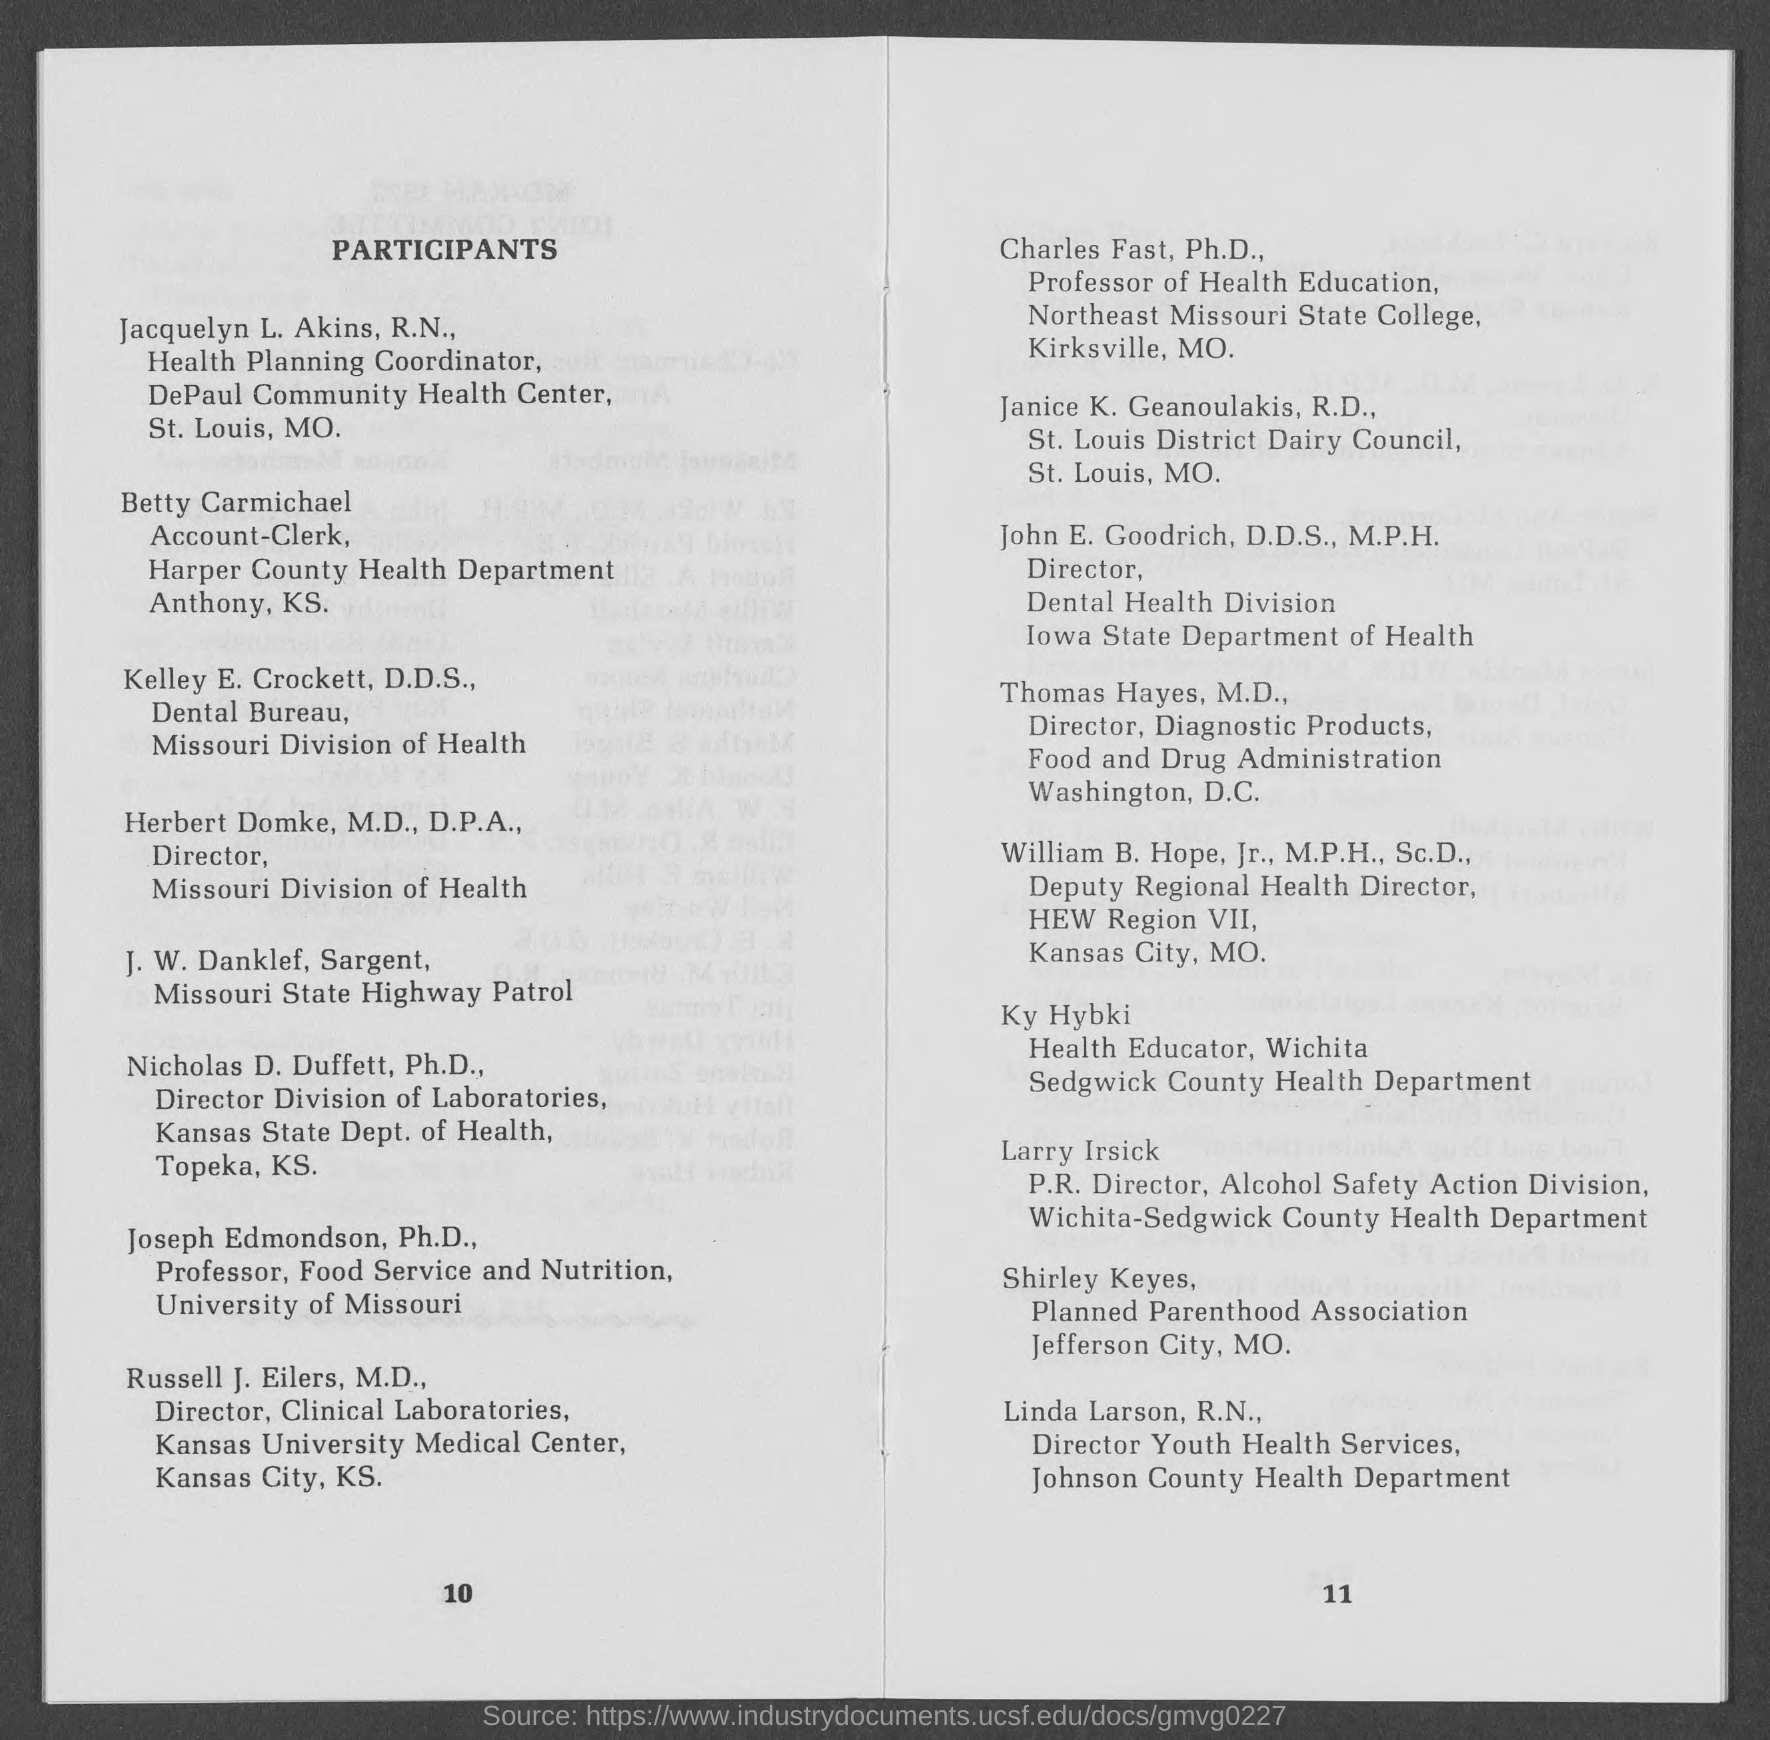What is the heading of document at top-left?
Provide a succinct answer. PARTICIPANTS. Who is the health planning coordinator at st.louis?
Your answer should be compact. JACQUELYN L. AKINS. Who is the account-clerk at anthony. k.s?
Make the answer very short. Betty Carmichael. Who is the director of Missouri Division of Health?
Keep it short and to the point. HERBERT DOMKE, M.D., D.P.A. Who is the director division of laboratories, kansas state dept. of health?
Provide a short and direct response. Nicholas D. Duffett, Ph.D. Who is the director of dental health division, iowa state department of health?
Make the answer very short. JOHN E. GOODRICH, D.D.S., M.P.H. Who is the director, diagnostic products, food and drug admistration?
Offer a very short reply. THOMAS HAYES, M.D. Who represents director youth health services, johnson county health department?
Your answer should be compact. Linda Larson, R.N. 